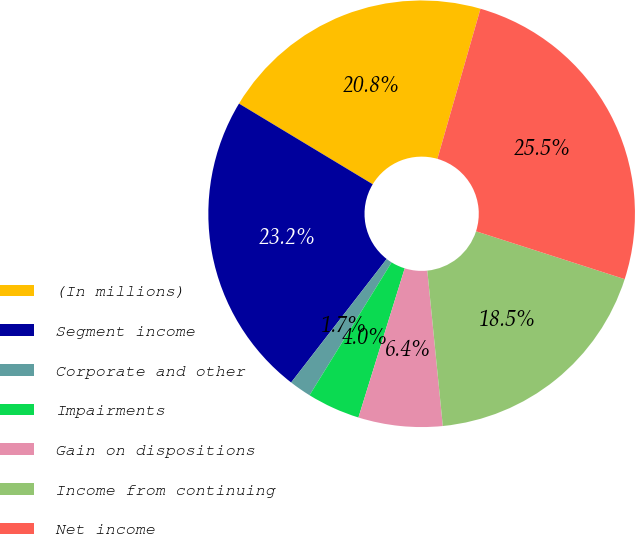Convert chart to OTSL. <chart><loc_0><loc_0><loc_500><loc_500><pie_chart><fcel>(In millions)<fcel>Segment income<fcel>Corporate and other<fcel>Impairments<fcel>Gain on dispositions<fcel>Income from continuing<fcel>Net income<nl><fcel>20.81%<fcel>23.16%<fcel>1.67%<fcel>4.02%<fcel>6.37%<fcel>18.46%<fcel>25.51%<nl></chart> 